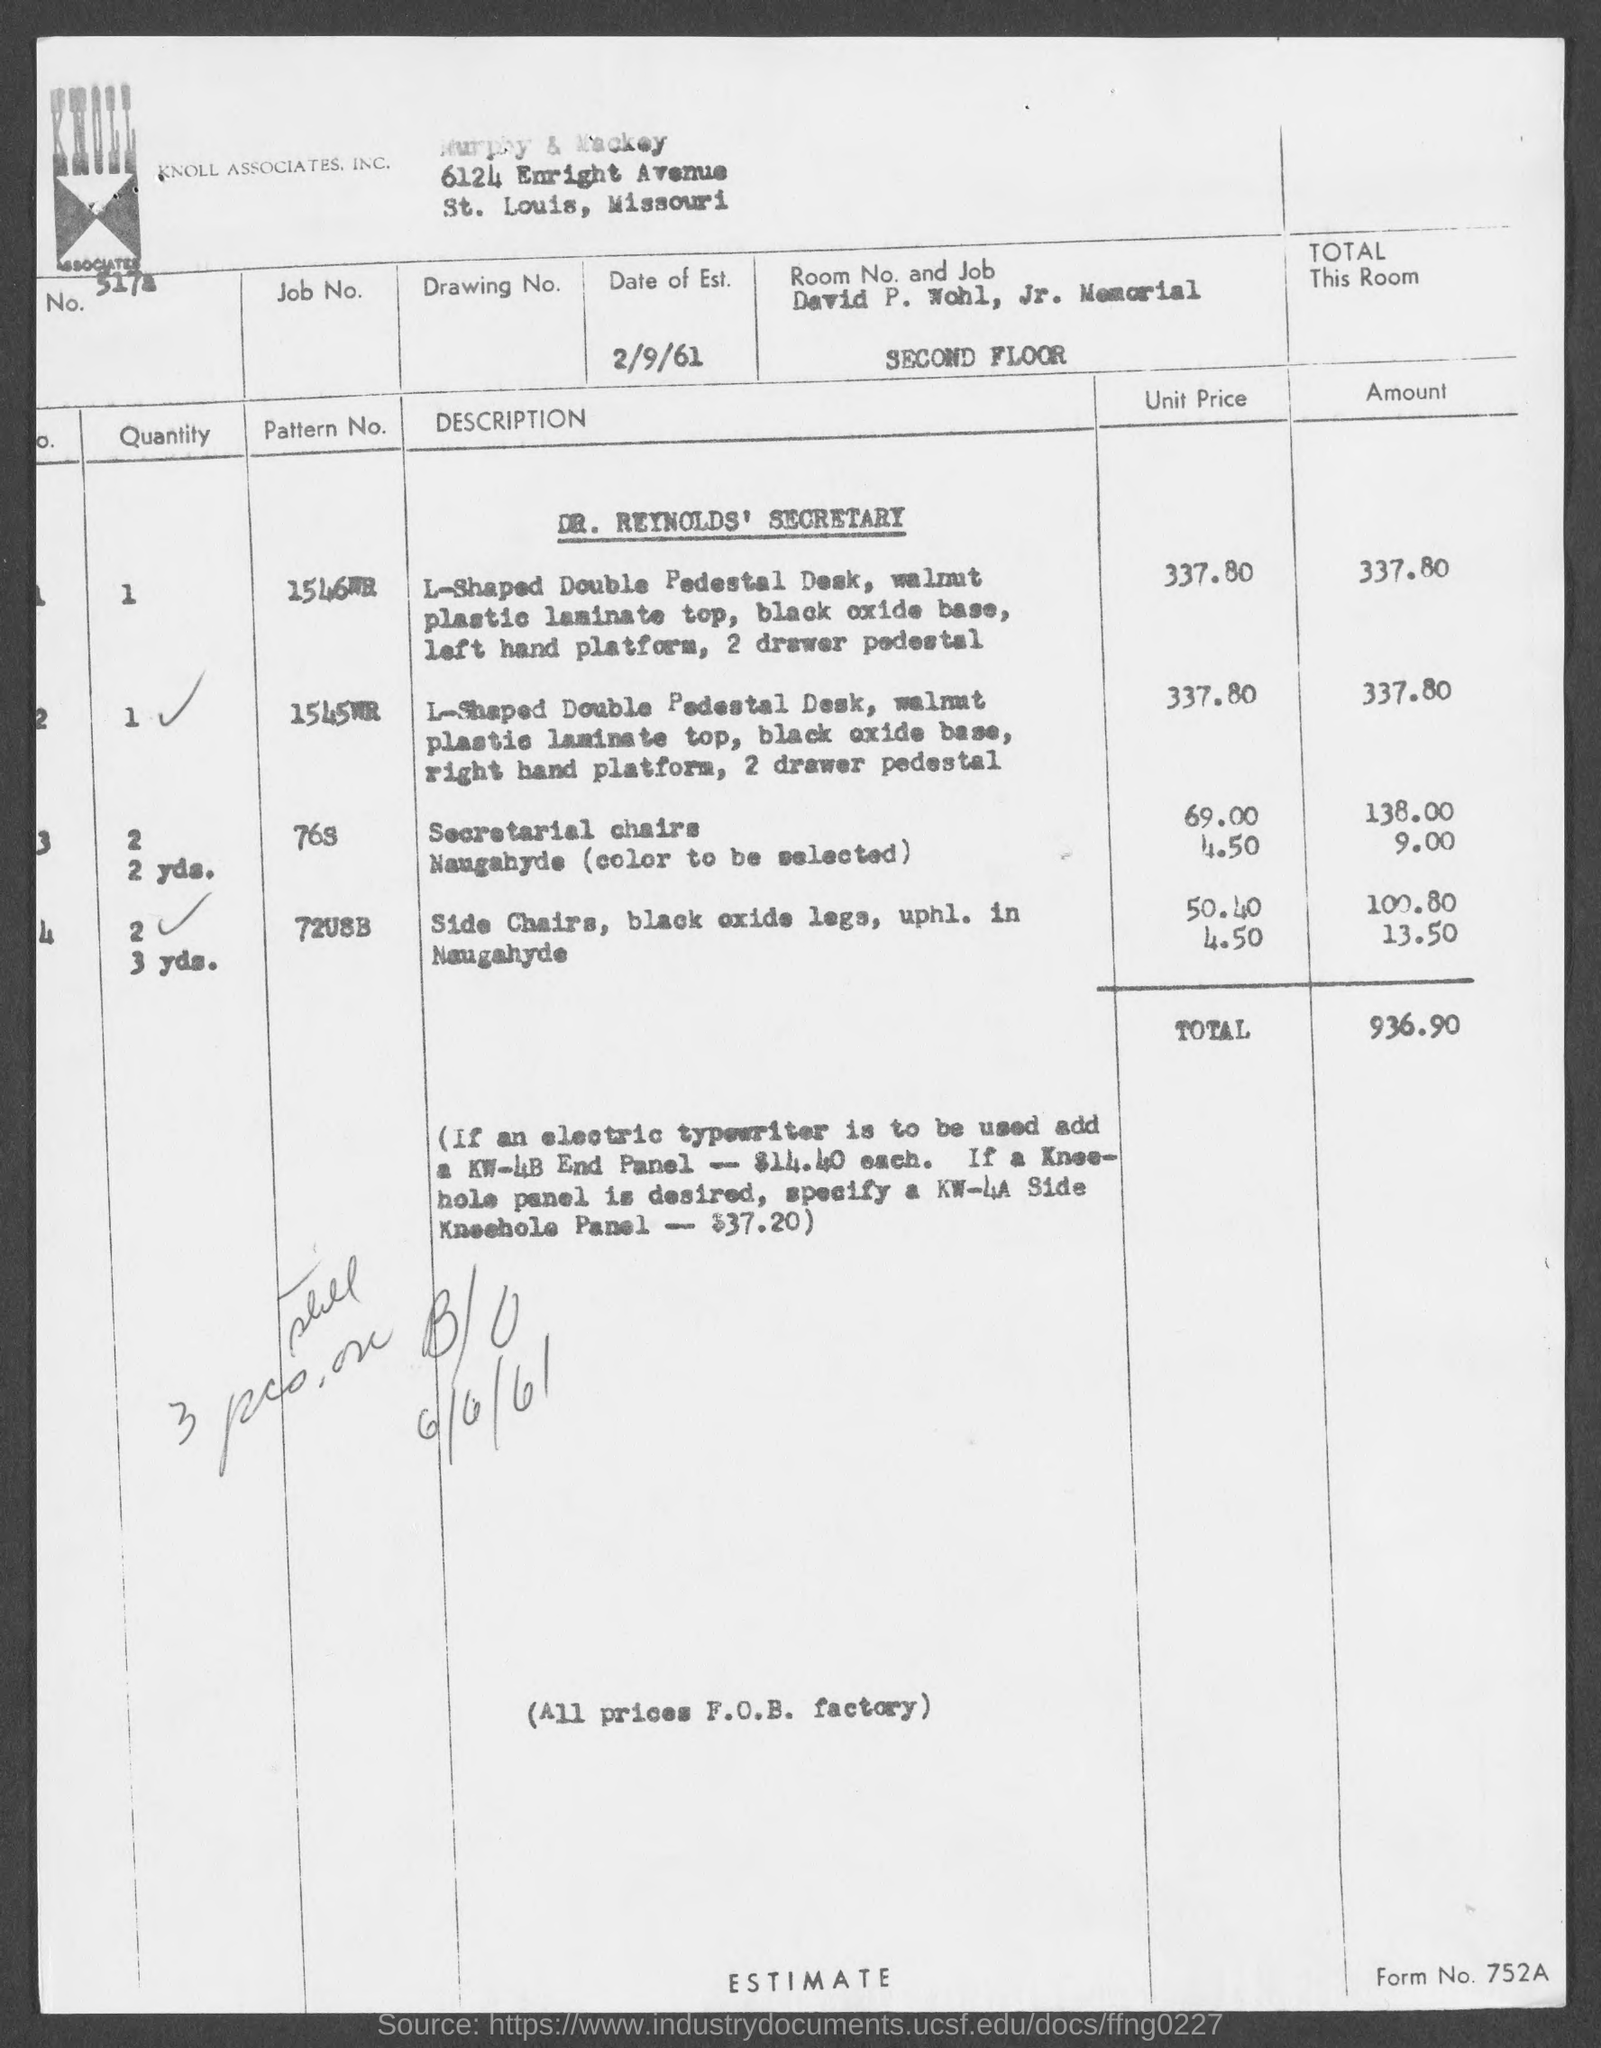What is the form no.?
Your answer should be compact. 752A. What is the total amount ?
Give a very brief answer. $936.90. In which state is murphy & mackey at ?
Your answer should be very brief. Missouri. 